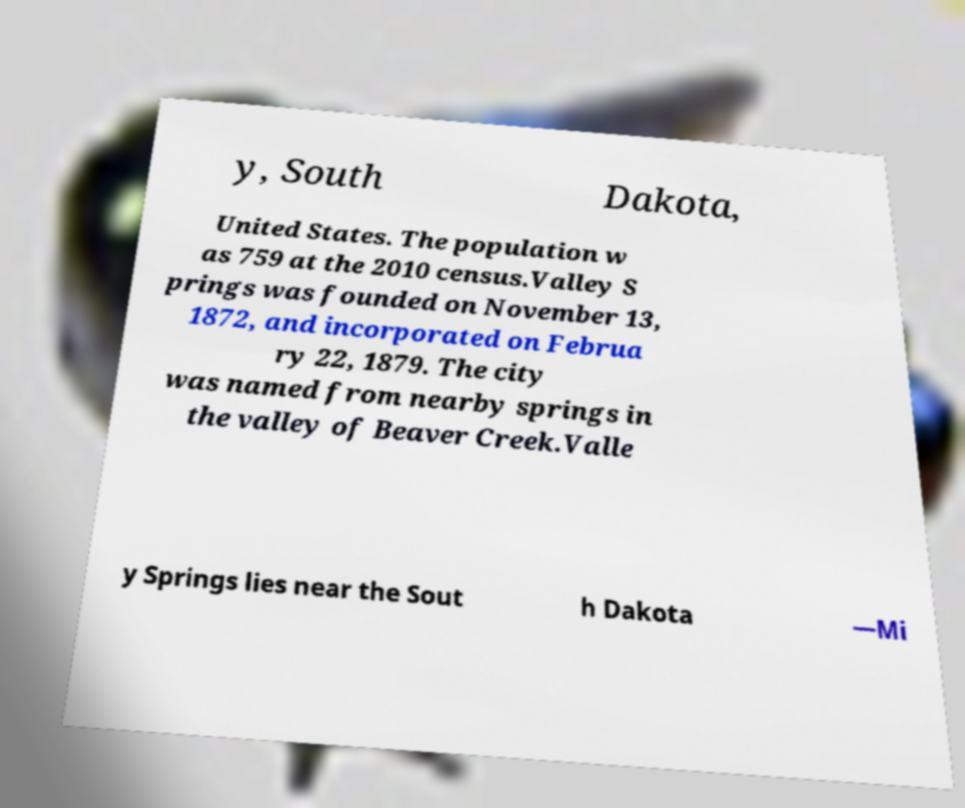Can you accurately transcribe the text from the provided image for me? y, South Dakota, United States. The population w as 759 at the 2010 census.Valley S prings was founded on November 13, 1872, and incorporated on Februa ry 22, 1879. The city was named from nearby springs in the valley of Beaver Creek.Valle y Springs lies near the Sout h Dakota —Mi 